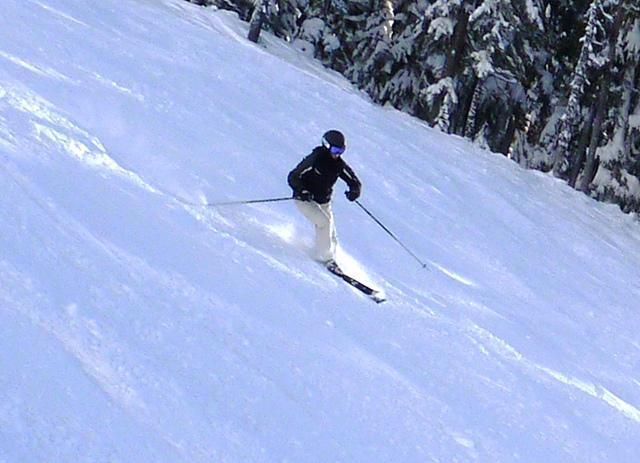How many animals that are zebras are there? there are animals that aren't zebras too?
Give a very brief answer. 0. 